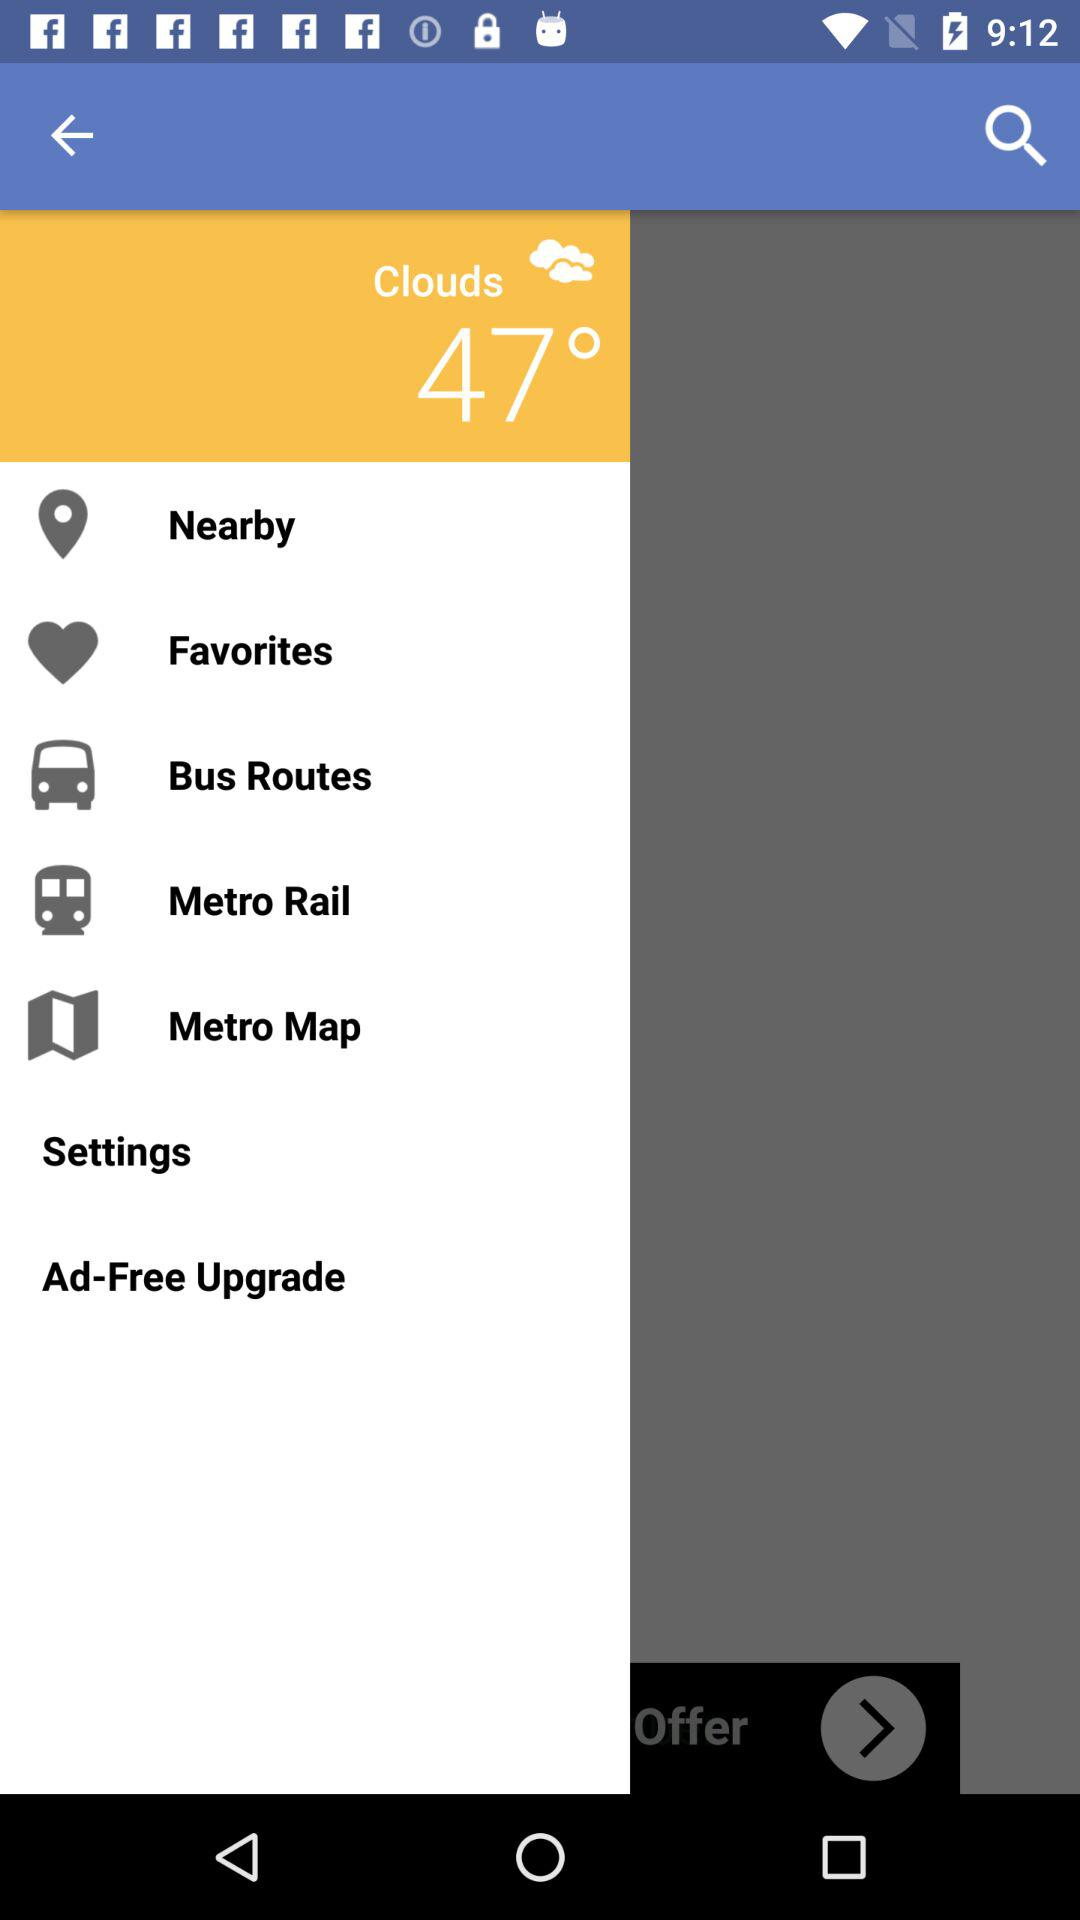What is the temperature? The temperature is 47°. 